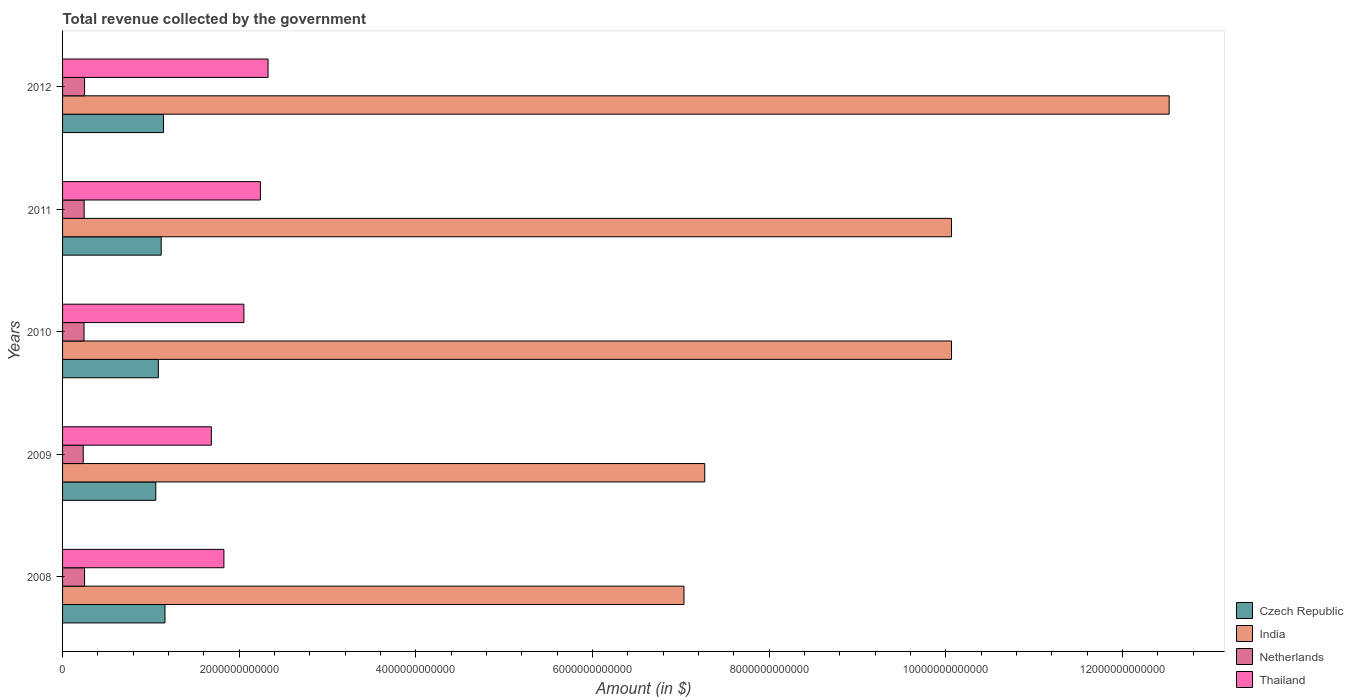How many different coloured bars are there?
Keep it short and to the point. 4. Are the number of bars per tick equal to the number of legend labels?
Provide a succinct answer. Yes. Are the number of bars on each tick of the Y-axis equal?
Give a very brief answer. Yes. How many bars are there on the 3rd tick from the bottom?
Your response must be concise. 4. In how many cases, is the number of bars for a given year not equal to the number of legend labels?
Offer a very short reply. 0. What is the total revenue collected by the government in India in 2008?
Give a very brief answer. 7.04e+12. Across all years, what is the maximum total revenue collected by the government in Thailand?
Offer a terse response. 2.33e+12. Across all years, what is the minimum total revenue collected by the government in India?
Offer a terse response. 7.04e+12. In which year was the total revenue collected by the government in Netherlands minimum?
Ensure brevity in your answer.  2009. What is the total total revenue collected by the government in India in the graph?
Make the answer very short. 4.70e+13. What is the difference between the total revenue collected by the government in India in 2008 and that in 2010?
Provide a succinct answer. -3.03e+12. What is the difference between the total revenue collected by the government in Netherlands in 2009 and the total revenue collected by the government in Thailand in 2011?
Give a very brief answer. -2.01e+12. What is the average total revenue collected by the government in Netherlands per year?
Your answer should be very brief. 2.44e+11. In the year 2009, what is the difference between the total revenue collected by the government in Thailand and total revenue collected by the government in Czech Republic?
Your answer should be compact. 6.29e+11. What is the ratio of the total revenue collected by the government in Czech Republic in 2008 to that in 2010?
Keep it short and to the point. 1.07. Is the total revenue collected by the government in Netherlands in 2009 less than that in 2012?
Offer a very short reply. Yes. What is the difference between the highest and the second highest total revenue collected by the government in Czech Republic?
Offer a terse response. 1.68e+1. What is the difference between the highest and the lowest total revenue collected by the government in Czech Republic?
Your answer should be very brief. 1.04e+11. In how many years, is the total revenue collected by the government in Czech Republic greater than the average total revenue collected by the government in Czech Republic taken over all years?
Make the answer very short. 3. Is it the case that in every year, the sum of the total revenue collected by the government in Netherlands and total revenue collected by the government in India is greater than the sum of total revenue collected by the government in Thailand and total revenue collected by the government in Czech Republic?
Your answer should be compact. Yes. What does the 4th bar from the bottom in 2010 represents?
Your answer should be compact. Thailand. What is the difference between two consecutive major ticks on the X-axis?
Ensure brevity in your answer.  2.00e+12. Does the graph contain grids?
Give a very brief answer. No. Where does the legend appear in the graph?
Give a very brief answer. Bottom right. How many legend labels are there?
Make the answer very short. 4. What is the title of the graph?
Give a very brief answer. Total revenue collected by the government. Does "Spain" appear as one of the legend labels in the graph?
Your response must be concise. No. What is the label or title of the X-axis?
Provide a short and direct response. Amount (in $). What is the label or title of the Y-axis?
Your answer should be compact. Years. What is the Amount (in $) in Czech Republic in 2008?
Your response must be concise. 1.16e+12. What is the Amount (in $) in India in 2008?
Offer a very short reply. 7.04e+12. What is the Amount (in $) of Netherlands in 2008?
Your answer should be very brief. 2.49e+11. What is the Amount (in $) of Thailand in 2008?
Provide a succinct answer. 1.83e+12. What is the Amount (in $) in Czech Republic in 2009?
Give a very brief answer. 1.06e+12. What is the Amount (in $) in India in 2009?
Provide a short and direct response. 7.27e+12. What is the Amount (in $) of Netherlands in 2009?
Give a very brief answer. 2.34e+11. What is the Amount (in $) of Thailand in 2009?
Your answer should be compact. 1.68e+12. What is the Amount (in $) in Czech Republic in 2010?
Offer a very short reply. 1.08e+12. What is the Amount (in $) in India in 2010?
Give a very brief answer. 1.01e+13. What is the Amount (in $) of Netherlands in 2010?
Your response must be concise. 2.43e+11. What is the Amount (in $) of Thailand in 2010?
Offer a very short reply. 2.05e+12. What is the Amount (in $) of Czech Republic in 2011?
Offer a very short reply. 1.12e+12. What is the Amount (in $) in India in 2011?
Ensure brevity in your answer.  1.01e+13. What is the Amount (in $) in Netherlands in 2011?
Your response must be concise. 2.44e+11. What is the Amount (in $) in Thailand in 2011?
Ensure brevity in your answer.  2.24e+12. What is the Amount (in $) in Czech Republic in 2012?
Your answer should be compact. 1.14e+12. What is the Amount (in $) of India in 2012?
Offer a very short reply. 1.25e+13. What is the Amount (in $) of Netherlands in 2012?
Provide a short and direct response. 2.49e+11. What is the Amount (in $) of Thailand in 2012?
Your answer should be compact. 2.33e+12. Across all years, what is the maximum Amount (in $) of Czech Republic?
Provide a succinct answer. 1.16e+12. Across all years, what is the maximum Amount (in $) in India?
Give a very brief answer. 1.25e+13. Across all years, what is the maximum Amount (in $) of Netherlands?
Keep it short and to the point. 2.49e+11. Across all years, what is the maximum Amount (in $) in Thailand?
Provide a succinct answer. 2.33e+12. Across all years, what is the minimum Amount (in $) in Czech Republic?
Offer a terse response. 1.06e+12. Across all years, what is the minimum Amount (in $) in India?
Make the answer very short. 7.04e+12. Across all years, what is the minimum Amount (in $) of Netherlands?
Your response must be concise. 2.34e+11. Across all years, what is the minimum Amount (in $) in Thailand?
Your answer should be compact. 1.68e+12. What is the total Amount (in $) of Czech Republic in the graph?
Give a very brief answer. 5.56e+12. What is the total Amount (in $) of India in the graph?
Give a very brief answer. 4.70e+13. What is the total Amount (in $) in Netherlands in the graph?
Your response must be concise. 1.22e+12. What is the total Amount (in $) in Thailand in the graph?
Keep it short and to the point. 1.01e+13. What is the difference between the Amount (in $) in Czech Republic in 2008 and that in 2009?
Offer a very short reply. 1.04e+11. What is the difference between the Amount (in $) of India in 2008 and that in 2009?
Your response must be concise. -2.35e+11. What is the difference between the Amount (in $) of Netherlands in 2008 and that in 2009?
Make the answer very short. 1.51e+1. What is the difference between the Amount (in $) of Thailand in 2008 and that in 2009?
Keep it short and to the point. 1.42e+11. What is the difference between the Amount (in $) in Czech Republic in 2008 and that in 2010?
Offer a very short reply. 7.46e+1. What is the difference between the Amount (in $) in India in 2008 and that in 2010?
Provide a succinct answer. -3.03e+12. What is the difference between the Amount (in $) of Netherlands in 2008 and that in 2010?
Give a very brief answer. 6.16e+09. What is the difference between the Amount (in $) in Thailand in 2008 and that in 2010?
Give a very brief answer. -2.27e+11. What is the difference between the Amount (in $) of Czech Republic in 2008 and that in 2011?
Make the answer very short. 4.26e+1. What is the difference between the Amount (in $) of India in 2008 and that in 2011?
Ensure brevity in your answer.  -3.03e+12. What is the difference between the Amount (in $) of Netherlands in 2008 and that in 2011?
Provide a short and direct response. 4.76e+09. What is the difference between the Amount (in $) of Thailand in 2008 and that in 2011?
Provide a short and direct response. -4.13e+11. What is the difference between the Amount (in $) of Czech Republic in 2008 and that in 2012?
Ensure brevity in your answer.  1.68e+1. What is the difference between the Amount (in $) in India in 2008 and that in 2012?
Offer a terse response. -5.49e+12. What is the difference between the Amount (in $) in Netherlands in 2008 and that in 2012?
Provide a succinct answer. -1.08e+08. What is the difference between the Amount (in $) in Thailand in 2008 and that in 2012?
Provide a succinct answer. -5.00e+11. What is the difference between the Amount (in $) in Czech Republic in 2009 and that in 2010?
Offer a very short reply. -2.93e+1. What is the difference between the Amount (in $) of India in 2009 and that in 2010?
Keep it short and to the point. -2.79e+12. What is the difference between the Amount (in $) in Netherlands in 2009 and that in 2010?
Provide a short and direct response. -8.94e+09. What is the difference between the Amount (in $) of Thailand in 2009 and that in 2010?
Your answer should be compact. -3.69e+11. What is the difference between the Amount (in $) in Czech Republic in 2009 and that in 2011?
Provide a short and direct response. -6.14e+1. What is the difference between the Amount (in $) of India in 2009 and that in 2011?
Provide a succinct answer. -2.79e+12. What is the difference between the Amount (in $) of Netherlands in 2009 and that in 2011?
Provide a succinct answer. -1.03e+1. What is the difference between the Amount (in $) of Thailand in 2009 and that in 2011?
Your response must be concise. -5.56e+11. What is the difference between the Amount (in $) in Czech Republic in 2009 and that in 2012?
Your answer should be very brief. -8.71e+1. What is the difference between the Amount (in $) in India in 2009 and that in 2012?
Offer a very short reply. -5.26e+12. What is the difference between the Amount (in $) of Netherlands in 2009 and that in 2012?
Provide a short and direct response. -1.52e+1. What is the difference between the Amount (in $) of Thailand in 2009 and that in 2012?
Ensure brevity in your answer.  -6.42e+11. What is the difference between the Amount (in $) in Czech Republic in 2010 and that in 2011?
Your response must be concise. -3.21e+1. What is the difference between the Amount (in $) of India in 2010 and that in 2011?
Provide a succinct answer. 0. What is the difference between the Amount (in $) in Netherlands in 2010 and that in 2011?
Provide a succinct answer. -1.39e+09. What is the difference between the Amount (in $) in Thailand in 2010 and that in 2011?
Make the answer very short. -1.87e+11. What is the difference between the Amount (in $) of Czech Republic in 2010 and that in 2012?
Provide a short and direct response. -5.78e+1. What is the difference between the Amount (in $) in India in 2010 and that in 2012?
Offer a very short reply. -2.46e+12. What is the difference between the Amount (in $) in Netherlands in 2010 and that in 2012?
Your response must be concise. -6.26e+09. What is the difference between the Amount (in $) in Thailand in 2010 and that in 2012?
Offer a very short reply. -2.73e+11. What is the difference between the Amount (in $) in Czech Republic in 2011 and that in 2012?
Keep it short and to the point. -2.57e+1. What is the difference between the Amount (in $) in India in 2011 and that in 2012?
Keep it short and to the point. -2.46e+12. What is the difference between the Amount (in $) in Netherlands in 2011 and that in 2012?
Keep it short and to the point. -4.87e+09. What is the difference between the Amount (in $) of Thailand in 2011 and that in 2012?
Offer a very short reply. -8.64e+1. What is the difference between the Amount (in $) in Czech Republic in 2008 and the Amount (in $) in India in 2009?
Provide a short and direct response. -6.11e+12. What is the difference between the Amount (in $) of Czech Republic in 2008 and the Amount (in $) of Netherlands in 2009?
Provide a succinct answer. 9.25e+11. What is the difference between the Amount (in $) of Czech Republic in 2008 and the Amount (in $) of Thailand in 2009?
Your response must be concise. -5.25e+11. What is the difference between the Amount (in $) of India in 2008 and the Amount (in $) of Netherlands in 2009?
Offer a terse response. 6.80e+12. What is the difference between the Amount (in $) in India in 2008 and the Amount (in $) in Thailand in 2009?
Ensure brevity in your answer.  5.35e+12. What is the difference between the Amount (in $) in Netherlands in 2008 and the Amount (in $) in Thailand in 2009?
Your response must be concise. -1.44e+12. What is the difference between the Amount (in $) in Czech Republic in 2008 and the Amount (in $) in India in 2010?
Your answer should be compact. -8.91e+12. What is the difference between the Amount (in $) of Czech Republic in 2008 and the Amount (in $) of Netherlands in 2010?
Keep it short and to the point. 9.16e+11. What is the difference between the Amount (in $) of Czech Republic in 2008 and the Amount (in $) of Thailand in 2010?
Offer a very short reply. -8.94e+11. What is the difference between the Amount (in $) in India in 2008 and the Amount (in $) in Netherlands in 2010?
Your answer should be compact. 6.79e+12. What is the difference between the Amount (in $) in India in 2008 and the Amount (in $) in Thailand in 2010?
Your answer should be very brief. 4.98e+12. What is the difference between the Amount (in $) of Netherlands in 2008 and the Amount (in $) of Thailand in 2010?
Your answer should be compact. -1.80e+12. What is the difference between the Amount (in $) of Czech Republic in 2008 and the Amount (in $) of India in 2011?
Make the answer very short. -8.91e+12. What is the difference between the Amount (in $) in Czech Republic in 2008 and the Amount (in $) in Netherlands in 2011?
Give a very brief answer. 9.15e+11. What is the difference between the Amount (in $) of Czech Republic in 2008 and the Amount (in $) of Thailand in 2011?
Your response must be concise. -1.08e+12. What is the difference between the Amount (in $) of India in 2008 and the Amount (in $) of Netherlands in 2011?
Give a very brief answer. 6.79e+12. What is the difference between the Amount (in $) in India in 2008 and the Amount (in $) in Thailand in 2011?
Give a very brief answer. 4.80e+12. What is the difference between the Amount (in $) of Netherlands in 2008 and the Amount (in $) of Thailand in 2011?
Keep it short and to the point. -1.99e+12. What is the difference between the Amount (in $) in Czech Republic in 2008 and the Amount (in $) in India in 2012?
Keep it short and to the point. -1.14e+13. What is the difference between the Amount (in $) of Czech Republic in 2008 and the Amount (in $) of Netherlands in 2012?
Offer a very short reply. 9.10e+11. What is the difference between the Amount (in $) in Czech Republic in 2008 and the Amount (in $) in Thailand in 2012?
Offer a very short reply. -1.17e+12. What is the difference between the Amount (in $) of India in 2008 and the Amount (in $) of Netherlands in 2012?
Your answer should be very brief. 6.79e+12. What is the difference between the Amount (in $) of India in 2008 and the Amount (in $) of Thailand in 2012?
Provide a succinct answer. 4.71e+12. What is the difference between the Amount (in $) in Netherlands in 2008 and the Amount (in $) in Thailand in 2012?
Keep it short and to the point. -2.08e+12. What is the difference between the Amount (in $) of Czech Republic in 2009 and the Amount (in $) of India in 2010?
Offer a terse response. -9.01e+12. What is the difference between the Amount (in $) of Czech Republic in 2009 and the Amount (in $) of Netherlands in 2010?
Ensure brevity in your answer.  8.12e+11. What is the difference between the Amount (in $) in Czech Republic in 2009 and the Amount (in $) in Thailand in 2010?
Make the answer very short. -9.98e+11. What is the difference between the Amount (in $) of India in 2009 and the Amount (in $) of Netherlands in 2010?
Your answer should be very brief. 7.03e+12. What is the difference between the Amount (in $) of India in 2009 and the Amount (in $) of Thailand in 2010?
Provide a succinct answer. 5.22e+12. What is the difference between the Amount (in $) in Netherlands in 2009 and the Amount (in $) in Thailand in 2010?
Your answer should be compact. -1.82e+12. What is the difference between the Amount (in $) in Czech Republic in 2009 and the Amount (in $) in India in 2011?
Your answer should be compact. -9.01e+12. What is the difference between the Amount (in $) of Czech Republic in 2009 and the Amount (in $) of Netherlands in 2011?
Your answer should be very brief. 8.11e+11. What is the difference between the Amount (in $) of Czech Republic in 2009 and the Amount (in $) of Thailand in 2011?
Your response must be concise. -1.18e+12. What is the difference between the Amount (in $) in India in 2009 and the Amount (in $) in Netherlands in 2011?
Ensure brevity in your answer.  7.03e+12. What is the difference between the Amount (in $) of India in 2009 and the Amount (in $) of Thailand in 2011?
Your response must be concise. 5.03e+12. What is the difference between the Amount (in $) in Netherlands in 2009 and the Amount (in $) in Thailand in 2011?
Your answer should be very brief. -2.01e+12. What is the difference between the Amount (in $) of Czech Republic in 2009 and the Amount (in $) of India in 2012?
Make the answer very short. -1.15e+13. What is the difference between the Amount (in $) in Czech Republic in 2009 and the Amount (in $) in Netherlands in 2012?
Your answer should be compact. 8.06e+11. What is the difference between the Amount (in $) in Czech Republic in 2009 and the Amount (in $) in Thailand in 2012?
Ensure brevity in your answer.  -1.27e+12. What is the difference between the Amount (in $) in India in 2009 and the Amount (in $) in Netherlands in 2012?
Provide a short and direct response. 7.02e+12. What is the difference between the Amount (in $) in India in 2009 and the Amount (in $) in Thailand in 2012?
Keep it short and to the point. 4.94e+12. What is the difference between the Amount (in $) of Netherlands in 2009 and the Amount (in $) of Thailand in 2012?
Keep it short and to the point. -2.09e+12. What is the difference between the Amount (in $) in Czech Republic in 2010 and the Amount (in $) in India in 2011?
Offer a very short reply. -8.98e+12. What is the difference between the Amount (in $) in Czech Republic in 2010 and the Amount (in $) in Netherlands in 2011?
Provide a succinct answer. 8.40e+11. What is the difference between the Amount (in $) in Czech Republic in 2010 and the Amount (in $) in Thailand in 2011?
Make the answer very short. -1.16e+12. What is the difference between the Amount (in $) of India in 2010 and the Amount (in $) of Netherlands in 2011?
Provide a short and direct response. 9.82e+12. What is the difference between the Amount (in $) in India in 2010 and the Amount (in $) in Thailand in 2011?
Provide a succinct answer. 7.82e+12. What is the difference between the Amount (in $) of Netherlands in 2010 and the Amount (in $) of Thailand in 2011?
Keep it short and to the point. -2.00e+12. What is the difference between the Amount (in $) of Czech Republic in 2010 and the Amount (in $) of India in 2012?
Your response must be concise. -1.14e+13. What is the difference between the Amount (in $) of Czech Republic in 2010 and the Amount (in $) of Netherlands in 2012?
Offer a very short reply. 8.35e+11. What is the difference between the Amount (in $) in Czech Republic in 2010 and the Amount (in $) in Thailand in 2012?
Your response must be concise. -1.24e+12. What is the difference between the Amount (in $) in India in 2010 and the Amount (in $) in Netherlands in 2012?
Keep it short and to the point. 9.82e+12. What is the difference between the Amount (in $) in India in 2010 and the Amount (in $) in Thailand in 2012?
Provide a succinct answer. 7.74e+12. What is the difference between the Amount (in $) in Netherlands in 2010 and the Amount (in $) in Thailand in 2012?
Offer a terse response. -2.08e+12. What is the difference between the Amount (in $) of Czech Republic in 2011 and the Amount (in $) of India in 2012?
Provide a succinct answer. -1.14e+13. What is the difference between the Amount (in $) in Czech Republic in 2011 and the Amount (in $) in Netherlands in 2012?
Your response must be concise. 8.68e+11. What is the difference between the Amount (in $) in Czech Republic in 2011 and the Amount (in $) in Thailand in 2012?
Keep it short and to the point. -1.21e+12. What is the difference between the Amount (in $) of India in 2011 and the Amount (in $) of Netherlands in 2012?
Make the answer very short. 9.82e+12. What is the difference between the Amount (in $) of India in 2011 and the Amount (in $) of Thailand in 2012?
Provide a short and direct response. 7.74e+12. What is the difference between the Amount (in $) of Netherlands in 2011 and the Amount (in $) of Thailand in 2012?
Ensure brevity in your answer.  -2.08e+12. What is the average Amount (in $) in Czech Republic per year?
Give a very brief answer. 1.11e+12. What is the average Amount (in $) of India per year?
Your answer should be compact. 9.39e+12. What is the average Amount (in $) in Netherlands per year?
Your answer should be compact. 2.44e+11. What is the average Amount (in $) of Thailand per year?
Offer a terse response. 2.03e+12. In the year 2008, what is the difference between the Amount (in $) of Czech Republic and Amount (in $) of India?
Keep it short and to the point. -5.88e+12. In the year 2008, what is the difference between the Amount (in $) in Czech Republic and Amount (in $) in Netherlands?
Keep it short and to the point. 9.10e+11. In the year 2008, what is the difference between the Amount (in $) in Czech Republic and Amount (in $) in Thailand?
Keep it short and to the point. -6.67e+11. In the year 2008, what is the difference between the Amount (in $) of India and Amount (in $) of Netherlands?
Your answer should be very brief. 6.79e+12. In the year 2008, what is the difference between the Amount (in $) in India and Amount (in $) in Thailand?
Provide a succinct answer. 5.21e+12. In the year 2008, what is the difference between the Amount (in $) in Netherlands and Amount (in $) in Thailand?
Your answer should be very brief. -1.58e+12. In the year 2009, what is the difference between the Amount (in $) of Czech Republic and Amount (in $) of India?
Your answer should be very brief. -6.22e+12. In the year 2009, what is the difference between the Amount (in $) of Czech Republic and Amount (in $) of Netherlands?
Offer a very short reply. 8.21e+11. In the year 2009, what is the difference between the Amount (in $) of Czech Republic and Amount (in $) of Thailand?
Offer a very short reply. -6.29e+11. In the year 2009, what is the difference between the Amount (in $) in India and Amount (in $) in Netherlands?
Provide a succinct answer. 7.04e+12. In the year 2009, what is the difference between the Amount (in $) of India and Amount (in $) of Thailand?
Give a very brief answer. 5.59e+12. In the year 2009, what is the difference between the Amount (in $) of Netherlands and Amount (in $) of Thailand?
Your answer should be very brief. -1.45e+12. In the year 2010, what is the difference between the Amount (in $) in Czech Republic and Amount (in $) in India?
Your answer should be compact. -8.98e+12. In the year 2010, what is the difference between the Amount (in $) in Czech Republic and Amount (in $) in Netherlands?
Your response must be concise. 8.42e+11. In the year 2010, what is the difference between the Amount (in $) of Czech Republic and Amount (in $) of Thailand?
Make the answer very short. -9.69e+11. In the year 2010, what is the difference between the Amount (in $) of India and Amount (in $) of Netherlands?
Keep it short and to the point. 9.82e+12. In the year 2010, what is the difference between the Amount (in $) in India and Amount (in $) in Thailand?
Provide a succinct answer. 8.01e+12. In the year 2010, what is the difference between the Amount (in $) of Netherlands and Amount (in $) of Thailand?
Keep it short and to the point. -1.81e+12. In the year 2011, what is the difference between the Amount (in $) of Czech Republic and Amount (in $) of India?
Offer a terse response. -8.95e+12. In the year 2011, what is the difference between the Amount (in $) in Czech Republic and Amount (in $) in Netherlands?
Your answer should be compact. 8.72e+11. In the year 2011, what is the difference between the Amount (in $) in Czech Republic and Amount (in $) in Thailand?
Offer a terse response. -1.12e+12. In the year 2011, what is the difference between the Amount (in $) in India and Amount (in $) in Netherlands?
Your answer should be very brief. 9.82e+12. In the year 2011, what is the difference between the Amount (in $) in India and Amount (in $) in Thailand?
Give a very brief answer. 7.82e+12. In the year 2011, what is the difference between the Amount (in $) in Netherlands and Amount (in $) in Thailand?
Your response must be concise. -2.00e+12. In the year 2012, what is the difference between the Amount (in $) of Czech Republic and Amount (in $) of India?
Provide a succinct answer. -1.14e+13. In the year 2012, what is the difference between the Amount (in $) of Czech Republic and Amount (in $) of Netherlands?
Give a very brief answer. 8.93e+11. In the year 2012, what is the difference between the Amount (in $) of Czech Republic and Amount (in $) of Thailand?
Provide a short and direct response. -1.18e+12. In the year 2012, what is the difference between the Amount (in $) in India and Amount (in $) in Netherlands?
Offer a terse response. 1.23e+13. In the year 2012, what is the difference between the Amount (in $) of India and Amount (in $) of Thailand?
Keep it short and to the point. 1.02e+13. In the year 2012, what is the difference between the Amount (in $) in Netherlands and Amount (in $) in Thailand?
Your response must be concise. -2.08e+12. What is the ratio of the Amount (in $) of Czech Republic in 2008 to that in 2009?
Your response must be concise. 1.1. What is the ratio of the Amount (in $) of India in 2008 to that in 2009?
Your response must be concise. 0.97. What is the ratio of the Amount (in $) of Netherlands in 2008 to that in 2009?
Give a very brief answer. 1.06. What is the ratio of the Amount (in $) in Thailand in 2008 to that in 2009?
Your answer should be compact. 1.08. What is the ratio of the Amount (in $) in Czech Republic in 2008 to that in 2010?
Offer a very short reply. 1.07. What is the ratio of the Amount (in $) of India in 2008 to that in 2010?
Your response must be concise. 0.7. What is the ratio of the Amount (in $) of Netherlands in 2008 to that in 2010?
Offer a terse response. 1.03. What is the ratio of the Amount (in $) in Thailand in 2008 to that in 2010?
Give a very brief answer. 0.89. What is the ratio of the Amount (in $) in Czech Republic in 2008 to that in 2011?
Provide a short and direct response. 1.04. What is the ratio of the Amount (in $) in India in 2008 to that in 2011?
Offer a terse response. 0.7. What is the ratio of the Amount (in $) in Netherlands in 2008 to that in 2011?
Your answer should be very brief. 1.02. What is the ratio of the Amount (in $) of Thailand in 2008 to that in 2011?
Make the answer very short. 0.82. What is the ratio of the Amount (in $) in Czech Republic in 2008 to that in 2012?
Offer a terse response. 1.01. What is the ratio of the Amount (in $) in India in 2008 to that in 2012?
Provide a short and direct response. 0.56. What is the ratio of the Amount (in $) in Thailand in 2008 to that in 2012?
Make the answer very short. 0.79. What is the ratio of the Amount (in $) in India in 2009 to that in 2010?
Make the answer very short. 0.72. What is the ratio of the Amount (in $) in Netherlands in 2009 to that in 2010?
Your answer should be compact. 0.96. What is the ratio of the Amount (in $) of Thailand in 2009 to that in 2010?
Give a very brief answer. 0.82. What is the ratio of the Amount (in $) in Czech Republic in 2009 to that in 2011?
Make the answer very short. 0.94. What is the ratio of the Amount (in $) of India in 2009 to that in 2011?
Make the answer very short. 0.72. What is the ratio of the Amount (in $) of Netherlands in 2009 to that in 2011?
Provide a short and direct response. 0.96. What is the ratio of the Amount (in $) of Thailand in 2009 to that in 2011?
Your answer should be compact. 0.75. What is the ratio of the Amount (in $) of Czech Republic in 2009 to that in 2012?
Provide a short and direct response. 0.92. What is the ratio of the Amount (in $) of India in 2009 to that in 2012?
Give a very brief answer. 0.58. What is the ratio of the Amount (in $) in Netherlands in 2009 to that in 2012?
Provide a succinct answer. 0.94. What is the ratio of the Amount (in $) of Thailand in 2009 to that in 2012?
Make the answer very short. 0.72. What is the ratio of the Amount (in $) of Czech Republic in 2010 to that in 2011?
Ensure brevity in your answer.  0.97. What is the ratio of the Amount (in $) of Thailand in 2010 to that in 2011?
Ensure brevity in your answer.  0.92. What is the ratio of the Amount (in $) in Czech Republic in 2010 to that in 2012?
Your answer should be compact. 0.95. What is the ratio of the Amount (in $) of India in 2010 to that in 2012?
Your answer should be very brief. 0.8. What is the ratio of the Amount (in $) in Netherlands in 2010 to that in 2012?
Give a very brief answer. 0.97. What is the ratio of the Amount (in $) in Thailand in 2010 to that in 2012?
Make the answer very short. 0.88. What is the ratio of the Amount (in $) of Czech Republic in 2011 to that in 2012?
Provide a succinct answer. 0.98. What is the ratio of the Amount (in $) in India in 2011 to that in 2012?
Ensure brevity in your answer.  0.8. What is the ratio of the Amount (in $) in Netherlands in 2011 to that in 2012?
Your response must be concise. 0.98. What is the ratio of the Amount (in $) of Thailand in 2011 to that in 2012?
Your answer should be very brief. 0.96. What is the difference between the highest and the second highest Amount (in $) of Czech Republic?
Ensure brevity in your answer.  1.68e+1. What is the difference between the highest and the second highest Amount (in $) in India?
Provide a succinct answer. 2.46e+12. What is the difference between the highest and the second highest Amount (in $) of Netherlands?
Give a very brief answer. 1.08e+08. What is the difference between the highest and the second highest Amount (in $) in Thailand?
Offer a very short reply. 8.64e+1. What is the difference between the highest and the lowest Amount (in $) in Czech Republic?
Keep it short and to the point. 1.04e+11. What is the difference between the highest and the lowest Amount (in $) of India?
Ensure brevity in your answer.  5.49e+12. What is the difference between the highest and the lowest Amount (in $) of Netherlands?
Provide a succinct answer. 1.52e+1. What is the difference between the highest and the lowest Amount (in $) of Thailand?
Your answer should be compact. 6.42e+11. 